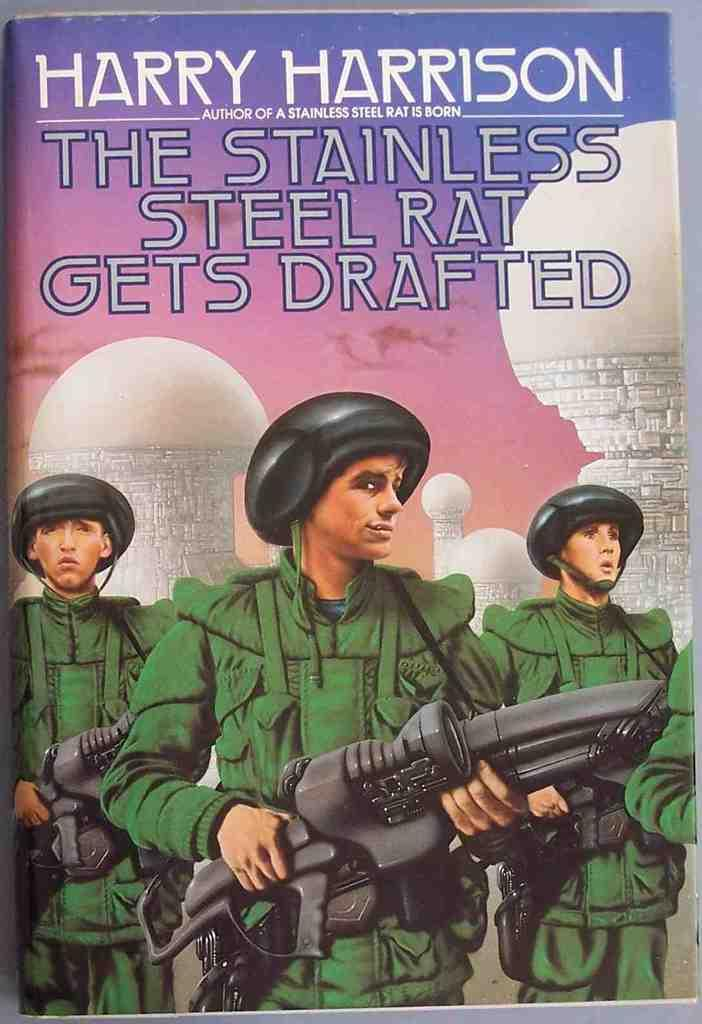<image>
Relay a brief, clear account of the picture shown. Cover showing three soldiers titled "The Stainless Steel Rat Gets Drafted". 